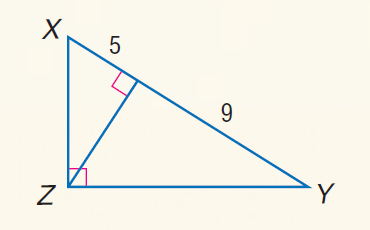Answer the mathemtical geometry problem and directly provide the correct option letter.
Question: Find the measure of the altitude drawn to the hypotenuse.
Choices: A: \sqrt { 3 } B: \sqrt { 5 } C: 3 D: 3 \sqrt { 5 } D 